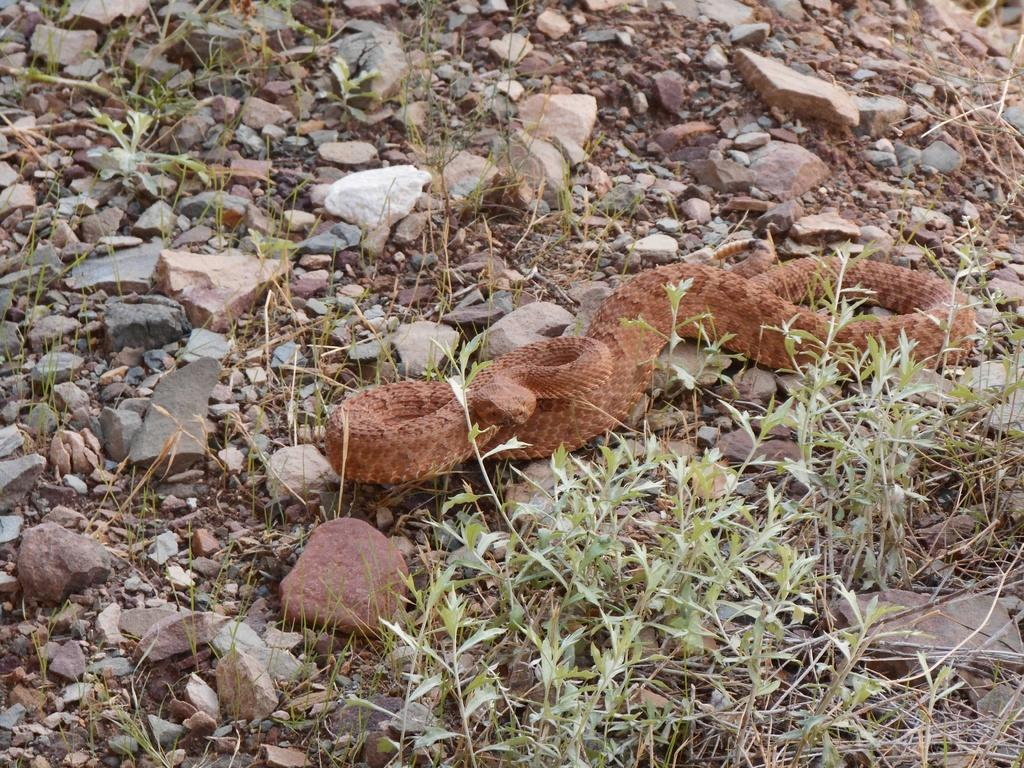What type of animal can be seen in the picture? There is a snake in the picture. What other objects or elements can be seen in the picture? There are stones, rocks, plants, and soil on the ground in the picture. How many eyes can be seen on the snake in the picture? The snake in the picture is a reptile, and reptiles typically have two eyes. However, since the image does not show the snake's eyes, we cannot definitively answer this question. 